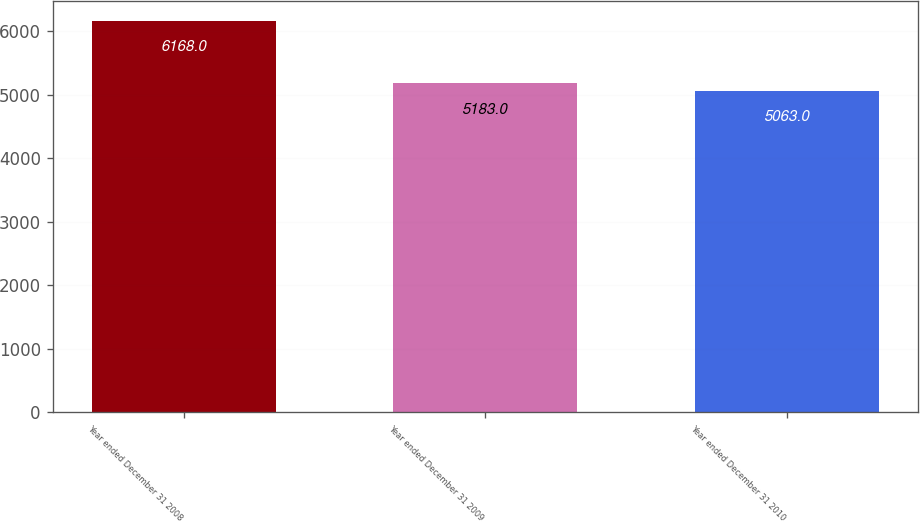<chart> <loc_0><loc_0><loc_500><loc_500><bar_chart><fcel>Year ended December 31 2008<fcel>Year ended December 31 2009<fcel>Year ended December 31 2010<nl><fcel>6168<fcel>5183<fcel>5063<nl></chart> 